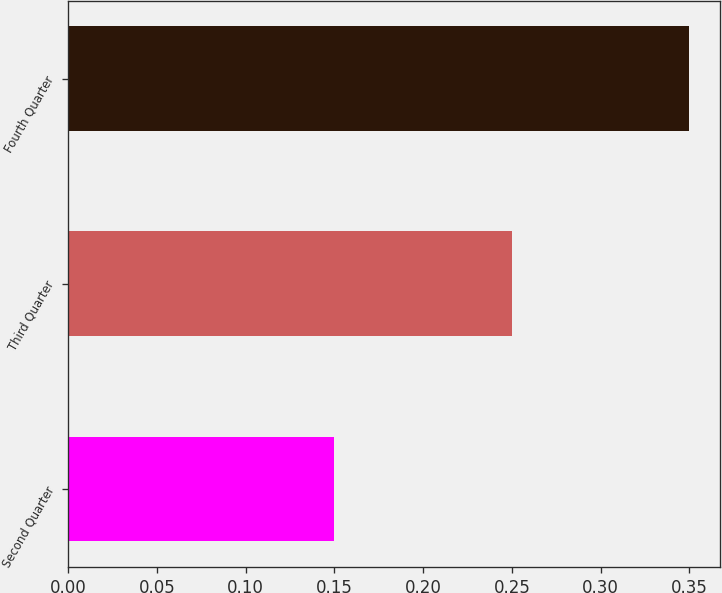Convert chart. <chart><loc_0><loc_0><loc_500><loc_500><bar_chart><fcel>Second Quarter<fcel>Third Quarter<fcel>Fourth Quarter<nl><fcel>0.15<fcel>0.25<fcel>0.35<nl></chart> 